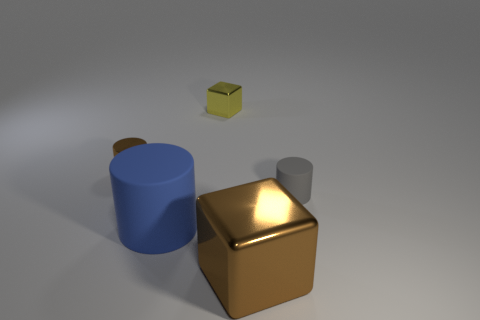Subtract all small cylinders. How many cylinders are left? 1 Add 4 small brown spheres. How many objects exist? 9 Subtract all cylinders. How many objects are left? 2 Add 4 gray objects. How many gray objects are left? 5 Add 2 gray rubber blocks. How many gray rubber blocks exist? 2 Subtract 0 yellow balls. How many objects are left? 5 Subtract all purple metallic cylinders. Subtract all yellow metallic objects. How many objects are left? 4 